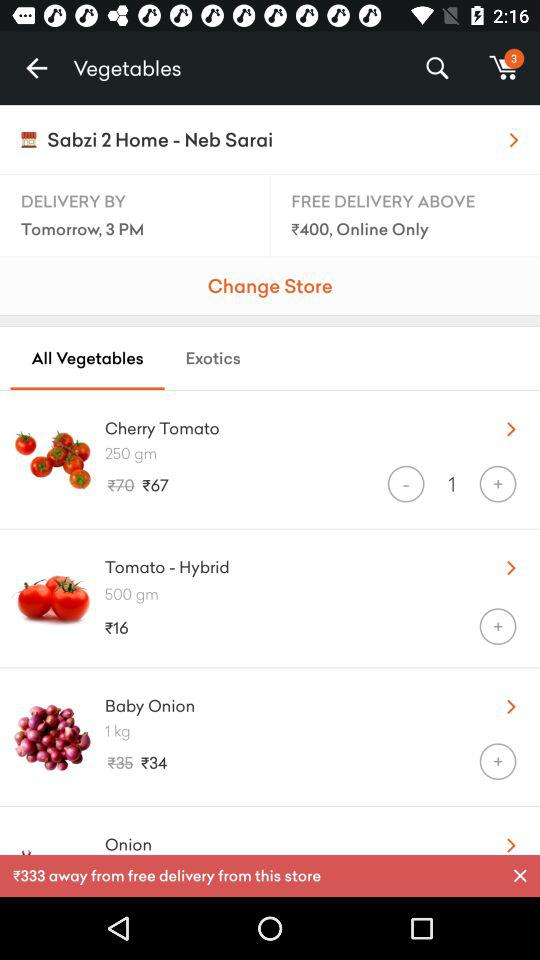How many more items are there in the cart than the number of items that are free with delivery?
Answer the question using a single word or phrase. 3 